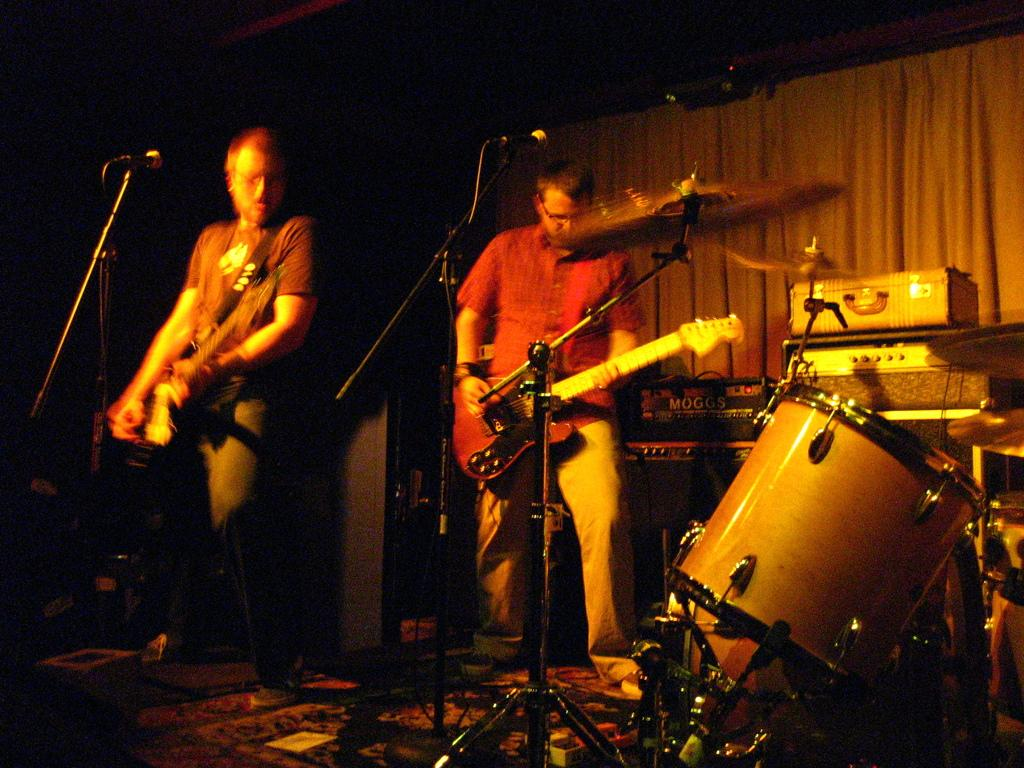How many people are in the image? There are two men in the image. What are the men doing in the image? The men are standing and holding guitars. Are there any other musical instruments in the image besides guitars? Yes, there are other musical instruments in the image. What is the name of the governor who is playing the drums in the image? There is no governor or drums present in the image. 